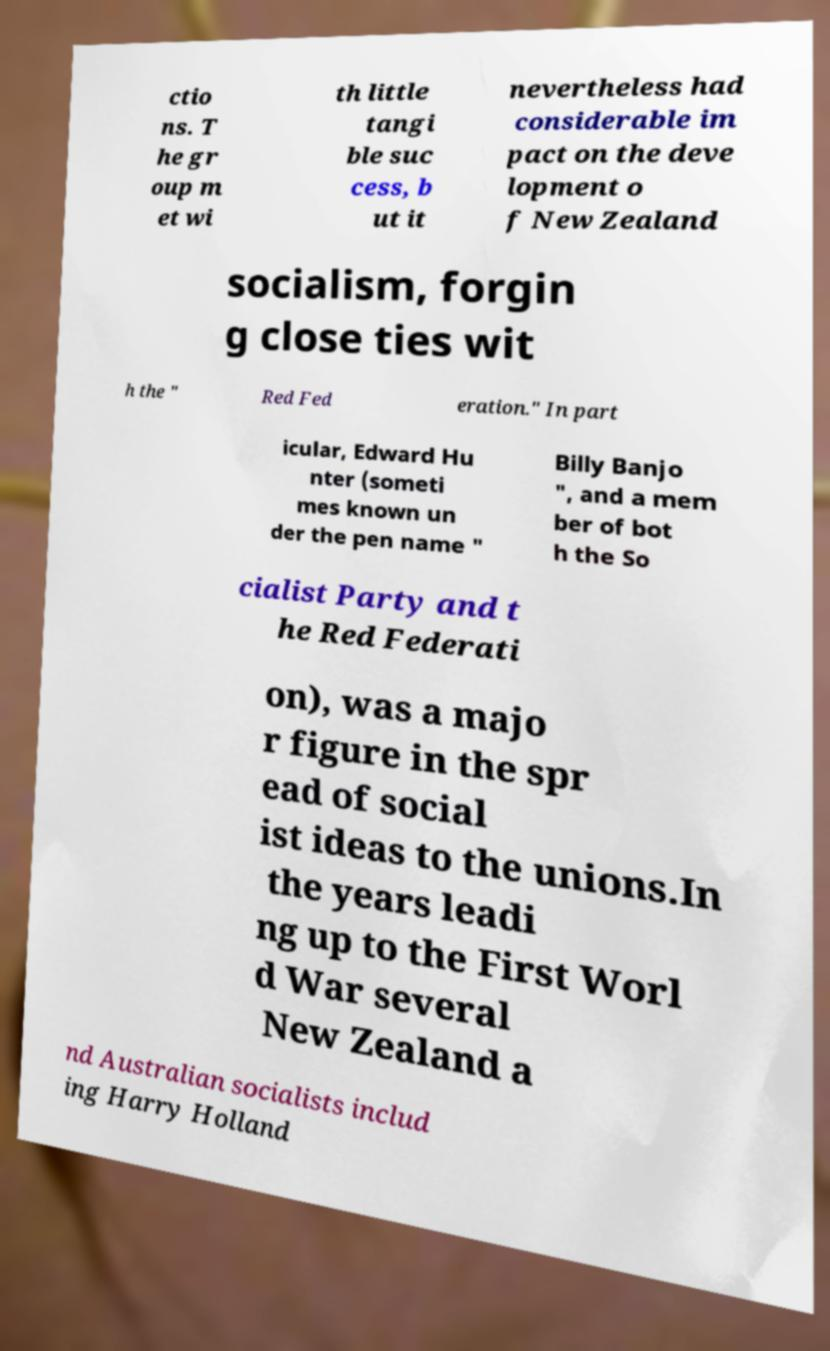Can you read and provide the text displayed in the image?This photo seems to have some interesting text. Can you extract and type it out for me? ctio ns. T he gr oup m et wi th little tangi ble suc cess, b ut it nevertheless had considerable im pact on the deve lopment o f New Zealand socialism, forgin g close ties wit h the " Red Fed eration." In part icular, Edward Hu nter (someti mes known un der the pen name " Billy Banjo ", and a mem ber of bot h the So cialist Party and t he Red Federati on), was a majo r figure in the spr ead of social ist ideas to the unions.In the years leadi ng up to the First Worl d War several New Zealand a nd Australian socialists includ ing Harry Holland 